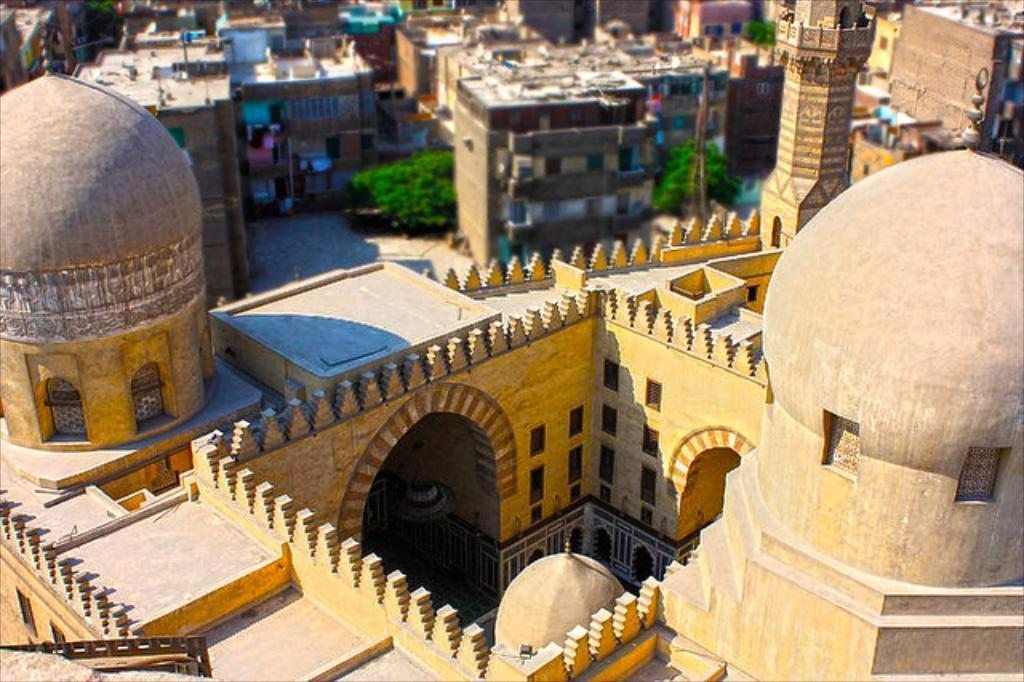What is the primary subject of the image? The primary subject of the image is many buildings. Can you describe any other elements present in the image? Yes, there are trees on the ground in the image. What type of church can be seen in the image? There is no church present in the image; it features many buildings and trees on the ground. Can you tell me how many drums are visible in the image? There are no drums present in the image. 